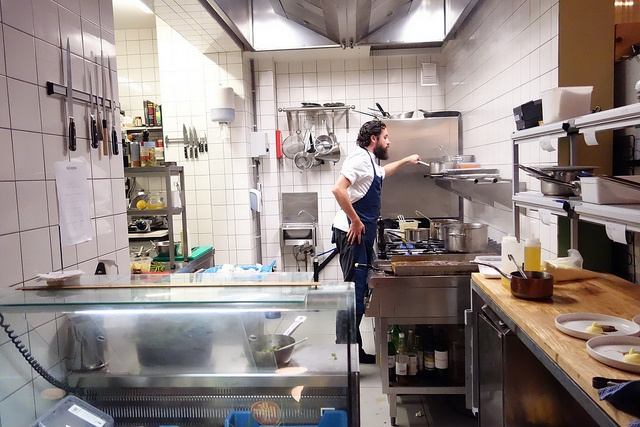Describe the objects in this image and their specific colors. I can see people in gray, black, white, and brown tones, refrigerator in gray and black tones, refrigerator in gray, tan, darkgray, and lightgray tones, oven in gray, black, maroon, and darkgray tones, and bowl in gray, darkgray, and black tones in this image. 